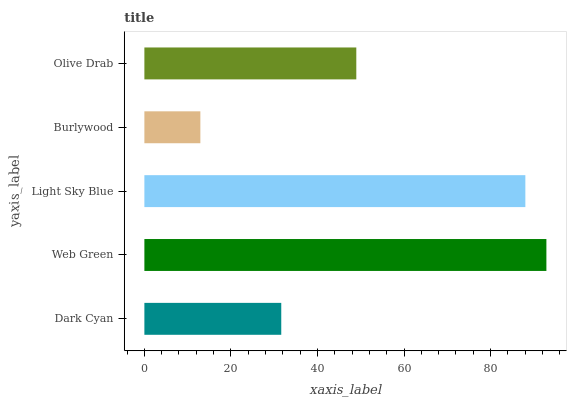Is Burlywood the minimum?
Answer yes or no. Yes. Is Web Green the maximum?
Answer yes or no. Yes. Is Light Sky Blue the minimum?
Answer yes or no. No. Is Light Sky Blue the maximum?
Answer yes or no. No. Is Web Green greater than Light Sky Blue?
Answer yes or no. Yes. Is Light Sky Blue less than Web Green?
Answer yes or no. Yes. Is Light Sky Blue greater than Web Green?
Answer yes or no. No. Is Web Green less than Light Sky Blue?
Answer yes or no. No. Is Olive Drab the high median?
Answer yes or no. Yes. Is Olive Drab the low median?
Answer yes or no. Yes. Is Dark Cyan the high median?
Answer yes or no. No. Is Burlywood the low median?
Answer yes or no. No. 